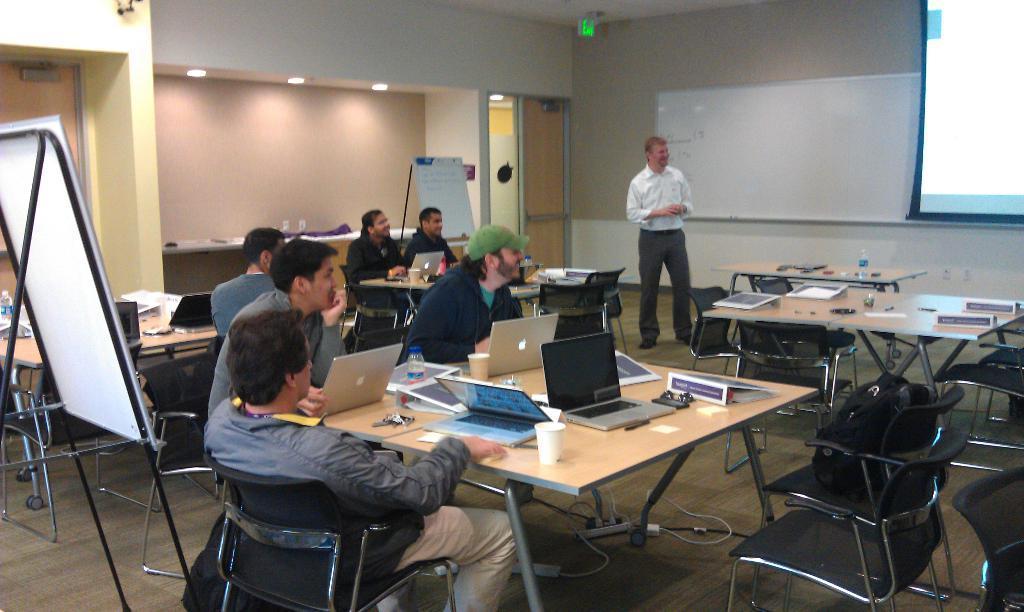How would you summarize this image in a sentence or two? In this image I can see people where one man is standing and rest all are sitting on chairs. I can also see few tables and on these tables I can see laptops and few more stuffs. Here I can see a projector's screen and a white board. 